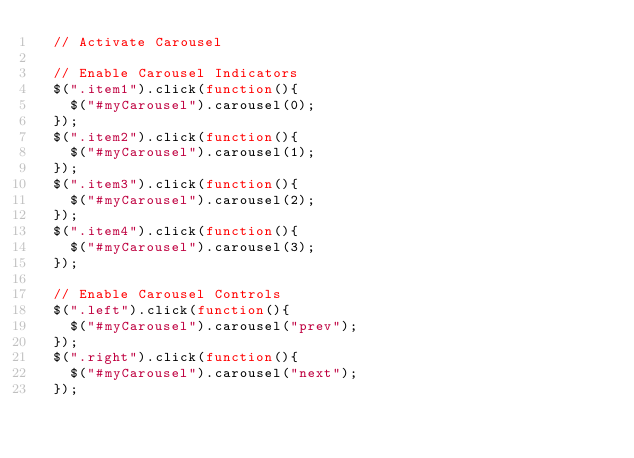<code> <loc_0><loc_0><loc_500><loc_500><_JavaScript_>  // Activate Carousel
      
  // Enable Carousel Indicators
  $(".item1").click(function(){
    $("#myCarousel").carousel(0);
  });
  $(".item2").click(function(){
    $("#myCarousel").carousel(1);
  });
  $(".item3").click(function(){
    $("#myCarousel").carousel(2);
  });
  $(".item4").click(function(){
    $("#myCarousel").carousel(3);
  });
    
  // Enable Carousel Controls
  $(".left").click(function(){
    $("#myCarousel").carousel("prev");
  });
  $(".right").click(function(){
    $("#myCarousel").carousel("next");
  });</code> 